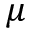<formula> <loc_0><loc_0><loc_500><loc_500>\mu</formula> 